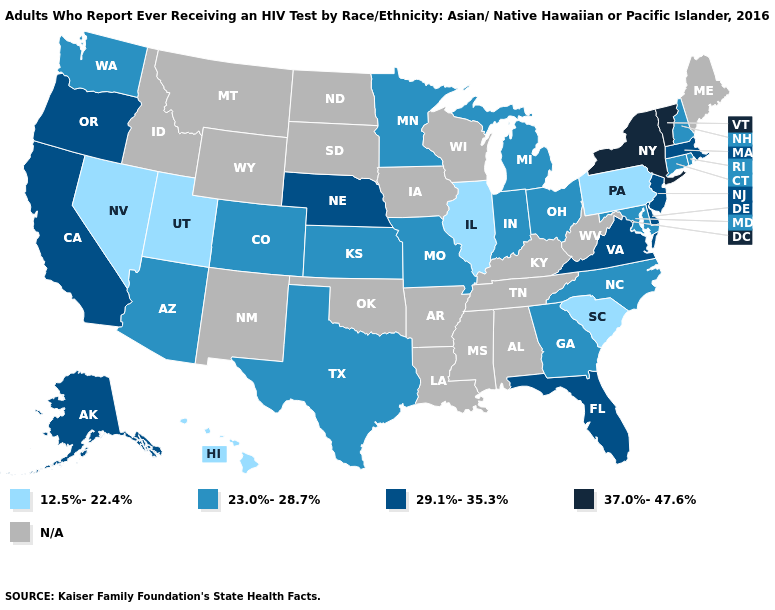Name the states that have a value in the range N/A?
Concise answer only. Alabama, Arkansas, Idaho, Iowa, Kentucky, Louisiana, Maine, Mississippi, Montana, New Mexico, North Dakota, Oklahoma, South Dakota, Tennessee, West Virginia, Wisconsin, Wyoming. Among the states that border Washington , which have the highest value?
Quick response, please. Oregon. What is the highest value in the MidWest ?
Short answer required. 29.1%-35.3%. Which states have the highest value in the USA?
Answer briefly. New York, Vermont. Which states have the lowest value in the USA?
Write a very short answer. Hawaii, Illinois, Nevada, Pennsylvania, South Carolina, Utah. Name the states that have a value in the range N/A?
Short answer required. Alabama, Arkansas, Idaho, Iowa, Kentucky, Louisiana, Maine, Mississippi, Montana, New Mexico, North Dakota, Oklahoma, South Dakota, Tennessee, West Virginia, Wisconsin, Wyoming. Name the states that have a value in the range 23.0%-28.7%?
Give a very brief answer. Arizona, Colorado, Connecticut, Georgia, Indiana, Kansas, Maryland, Michigan, Minnesota, Missouri, New Hampshire, North Carolina, Ohio, Rhode Island, Texas, Washington. Among the states that border Vermont , does New Hampshire have the highest value?
Keep it brief. No. What is the value of Oklahoma?
Keep it brief. N/A. What is the value of Maryland?
Concise answer only. 23.0%-28.7%. Name the states that have a value in the range 12.5%-22.4%?
Quick response, please. Hawaii, Illinois, Nevada, Pennsylvania, South Carolina, Utah. Among the states that border California , does Nevada have the highest value?
Write a very short answer. No. Among the states that border Georgia , does Florida have the highest value?
Write a very short answer. Yes. Among the states that border Rhode Island , does Connecticut have the lowest value?
Give a very brief answer. Yes. 